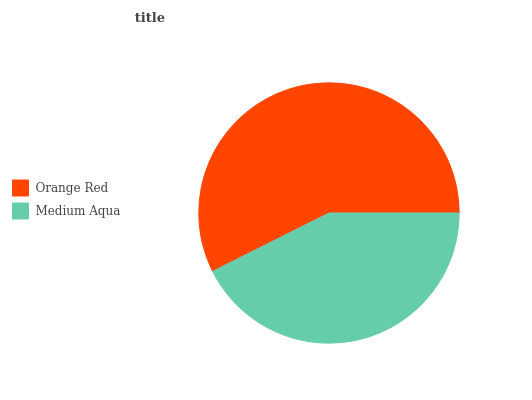Is Medium Aqua the minimum?
Answer yes or no. Yes. Is Orange Red the maximum?
Answer yes or no. Yes. Is Medium Aqua the maximum?
Answer yes or no. No. Is Orange Red greater than Medium Aqua?
Answer yes or no. Yes. Is Medium Aqua less than Orange Red?
Answer yes or no. Yes. Is Medium Aqua greater than Orange Red?
Answer yes or no. No. Is Orange Red less than Medium Aqua?
Answer yes or no. No. Is Orange Red the high median?
Answer yes or no. Yes. Is Medium Aqua the low median?
Answer yes or no. Yes. Is Medium Aqua the high median?
Answer yes or no. No. Is Orange Red the low median?
Answer yes or no. No. 